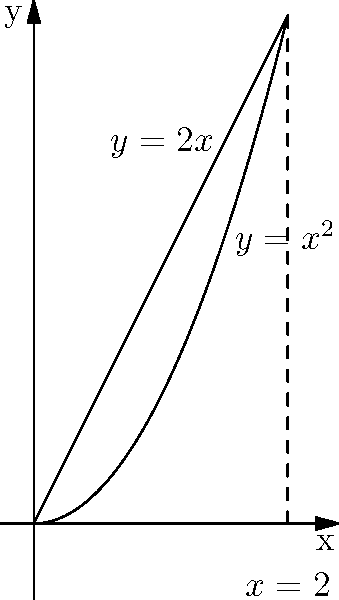Find the volume of the solid formed by rotating the region bounded by the curves $y=x^2$ and $y=2x$ around the y-axis. To find the volume using the shell method, we follow these steps:

1) Identify the limits of integration:
   The curves intersect at $x=0$ and $x=2$, so these are our limits.

2) Set up the integral using the shell method formula:
   $V = 2\pi \int_a^b x[f(x) - g(x)] dx$
   Where $f(x) = 2x$ (outer function) and $g(x) = x^2$ (inner function)

3) Substitute the functions and limits:
   $V = 2\pi \int_0^2 x[2x - x^2] dx$

4) Simplify the integrand:
   $V = 2\pi \int_0^2 (2x^2 - x^3) dx$

5) Integrate:
   $V = 2\pi [\frac{2x^3}{3} - \frac{x^4}{4}]_0^2$

6) Evaluate the definite integral:
   $V = 2\pi [(\frac{2(8)}{3} - \frac{16}{4}) - (0 - 0)]$
   $V = 2\pi [\frac{16}{3} - 4]$
   $V = 2\pi [\frac{16-12}{3}]$
   $V = 2\pi [\frac{4}{3}]$

7) Simplify:
   $V = \frac{8\pi}{3}$

Therefore, the volume of the solid is $\frac{8\pi}{3}$ cubic units.
Answer: $\frac{8\pi}{3}$ cubic units 